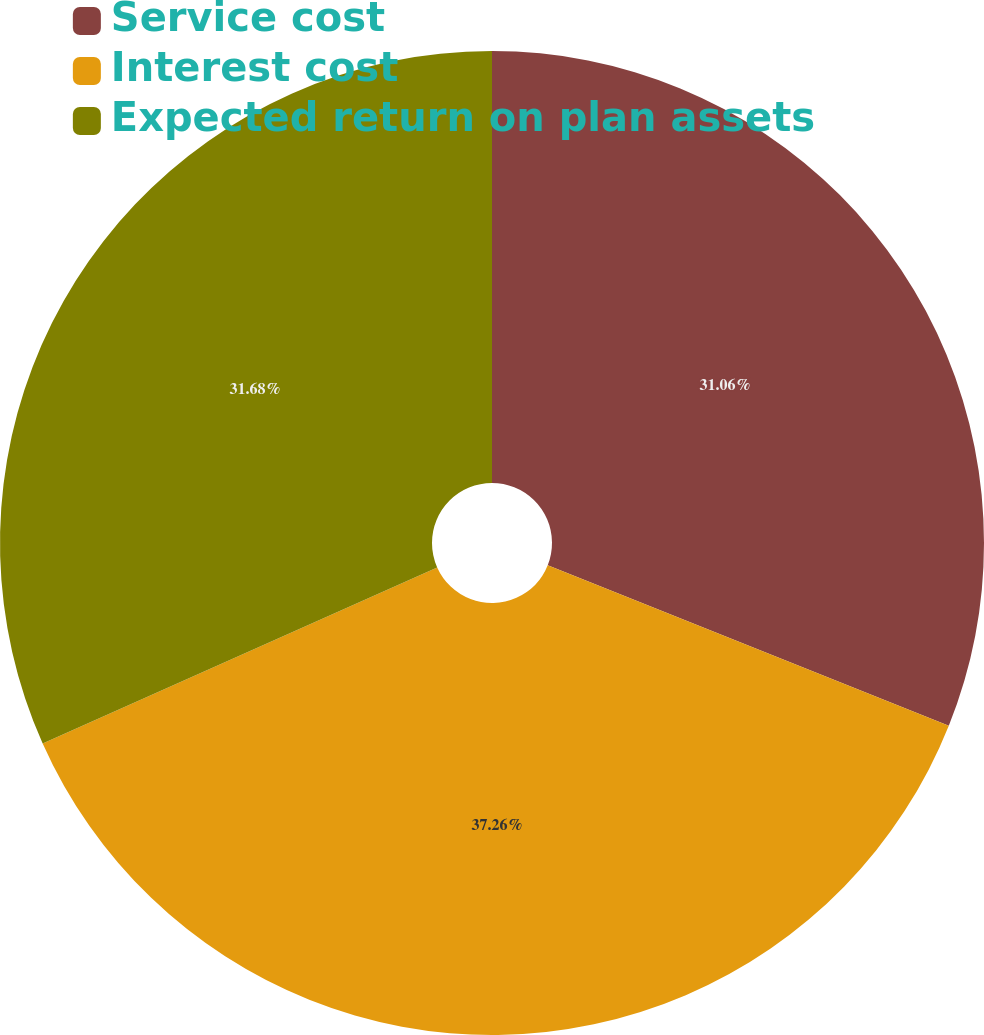<chart> <loc_0><loc_0><loc_500><loc_500><pie_chart><fcel>Service cost<fcel>Interest cost<fcel>Expected return on plan assets<nl><fcel>31.06%<fcel>37.27%<fcel>31.68%<nl></chart> 